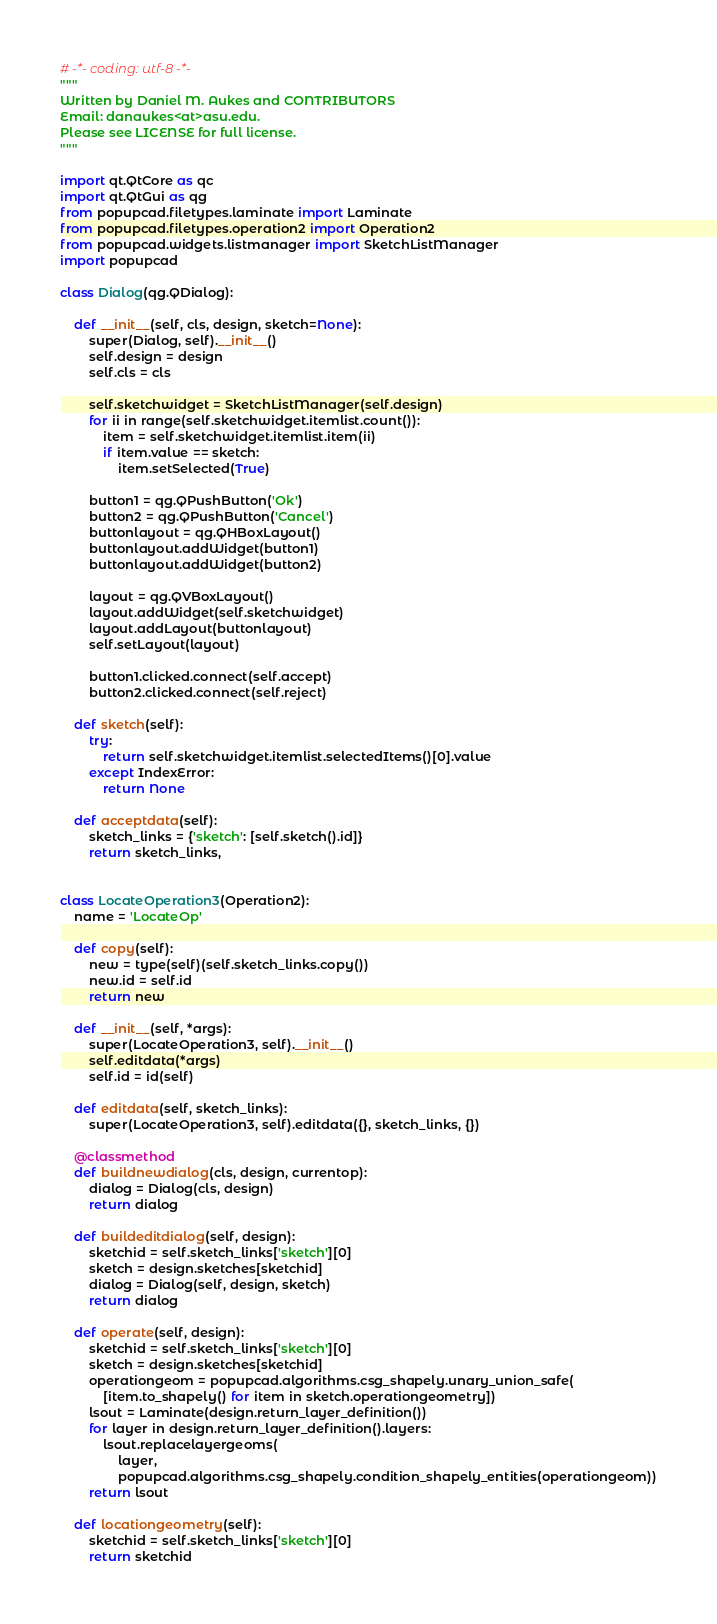<code> <loc_0><loc_0><loc_500><loc_500><_Python_># -*- coding: utf-8 -*-
"""
Written by Daniel M. Aukes and CONTRIBUTORS
Email: danaukes<at>asu.edu.
Please see LICENSE for full license.
"""

import qt.QtCore as qc
import qt.QtGui as qg
from popupcad.filetypes.laminate import Laminate
from popupcad.filetypes.operation2 import Operation2
from popupcad.widgets.listmanager import SketchListManager
import popupcad

class Dialog(qg.QDialog):

    def __init__(self, cls, design, sketch=None):
        super(Dialog, self).__init__()
        self.design = design
        self.cls = cls

        self.sketchwidget = SketchListManager(self.design)
        for ii in range(self.sketchwidget.itemlist.count()):
            item = self.sketchwidget.itemlist.item(ii)
            if item.value == sketch:
                item.setSelected(True)

        button1 = qg.QPushButton('Ok')
        button2 = qg.QPushButton('Cancel')
        buttonlayout = qg.QHBoxLayout()
        buttonlayout.addWidget(button1)
        buttonlayout.addWidget(button2)

        layout = qg.QVBoxLayout()
        layout.addWidget(self.sketchwidget)
        layout.addLayout(buttonlayout)
        self.setLayout(layout)

        button1.clicked.connect(self.accept)
        button2.clicked.connect(self.reject)

    def sketch(self):
        try:
            return self.sketchwidget.itemlist.selectedItems()[0].value
        except IndexError:
            return None

    def acceptdata(self):
        sketch_links = {'sketch': [self.sketch().id]}
        return sketch_links,


class LocateOperation3(Operation2):
    name = 'LocateOp'

    def copy(self):
        new = type(self)(self.sketch_links.copy())
        new.id = self.id
        return new

    def __init__(self, *args):
        super(LocateOperation3, self).__init__()
        self.editdata(*args)
        self.id = id(self)

    def editdata(self, sketch_links):
        super(LocateOperation3, self).editdata({}, sketch_links, {})

    @classmethod
    def buildnewdialog(cls, design, currentop):
        dialog = Dialog(cls, design)
        return dialog

    def buildeditdialog(self, design):
        sketchid = self.sketch_links['sketch'][0]
        sketch = design.sketches[sketchid]
        dialog = Dialog(self, design, sketch)
        return dialog

    def operate(self, design):
        sketchid = self.sketch_links['sketch'][0]
        sketch = design.sketches[sketchid]
        operationgeom = popupcad.algorithms.csg_shapely.unary_union_safe(
            [item.to_shapely() for item in sketch.operationgeometry])
        lsout = Laminate(design.return_layer_definition())
        for layer in design.return_layer_definition().layers:
            lsout.replacelayergeoms(
                layer,
                popupcad.algorithms.csg_shapely.condition_shapely_entities(operationgeom))
        return lsout

    def locationgeometry(self):
        sketchid = self.sketch_links['sketch'][0]
        return sketchid
</code> 